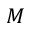Convert formula to latex. <formula><loc_0><loc_0><loc_500><loc_500>M</formula> 